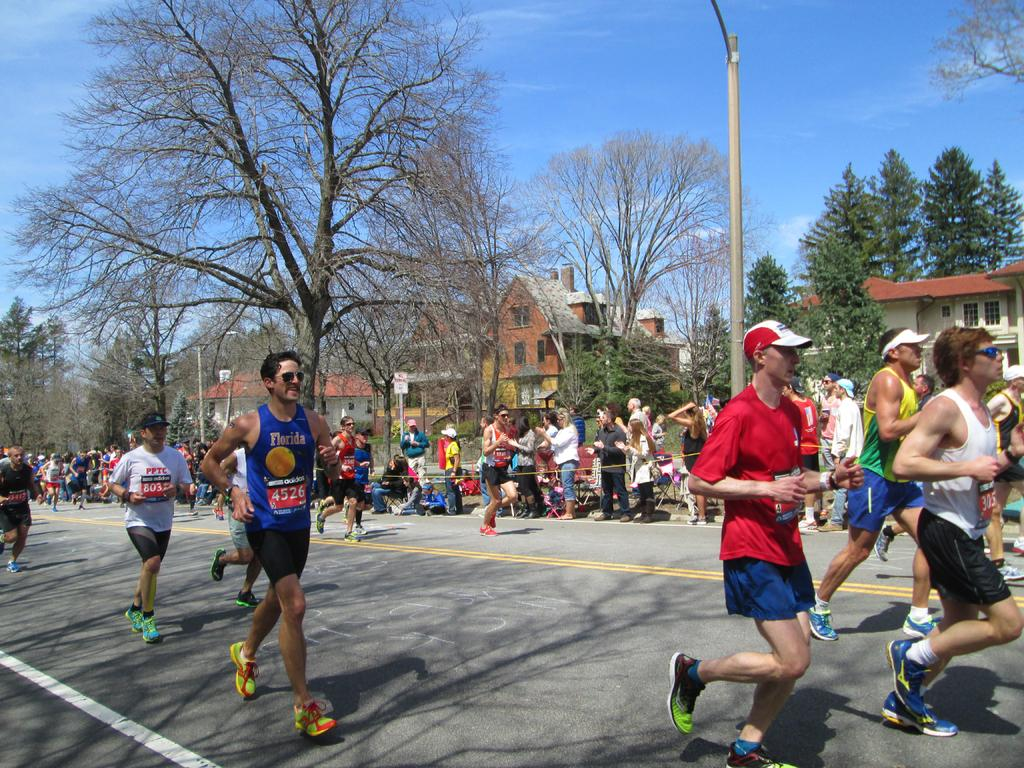How many people are in the image? There is a group of people in the image, but the exact number cannot be determined from the provided facts. What are some of the people in the image doing? Some people in the image are running on the road. What can be seen in the background of the image? In the background of the image, there are buildings, houses, trees, plants, poles, boards, and the sky. Can you describe the setting of the image? The image appears to be set in an urban or suburban area, with a mix of residential and commercial structures visible in the background. What type of hydrant can be seen spraying water in the image? There is no hydrant present in the image, and therefore no such activity can be observed. What punishment is being given to the people running on the road in the image? There is no indication in the image that the people running on the road are being punished, nor is there any mention of punishment in the provided facts. 